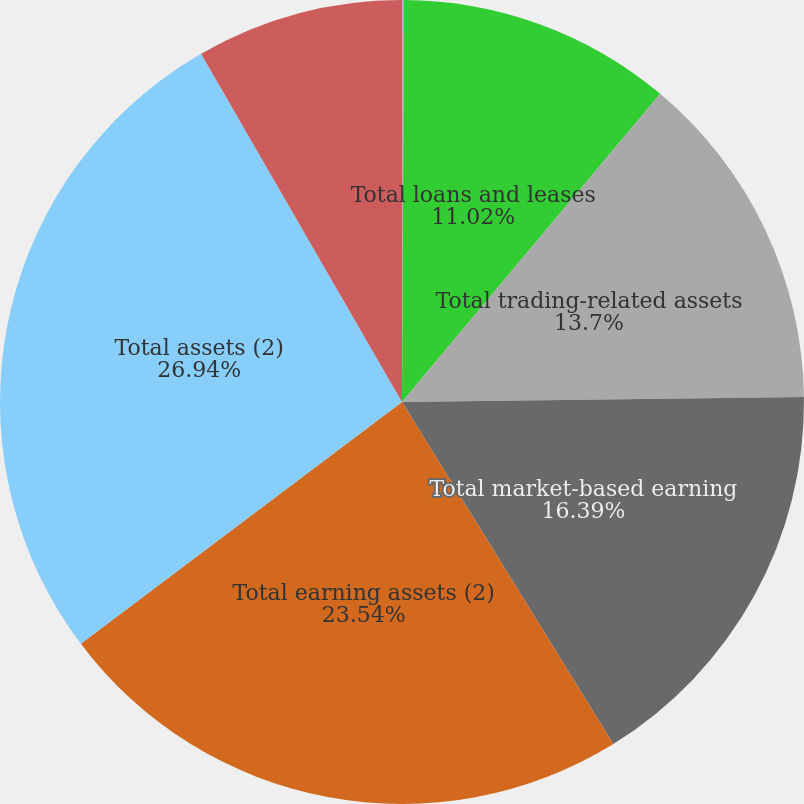Convert chart. <chart><loc_0><loc_0><loc_500><loc_500><pie_chart><fcel>(Dollars in millions)<fcel>Total loans and leases<fcel>Total trading-related assets<fcel>Total market-based earning<fcel>Total earning assets (2)<fcel>Total assets (2)<fcel>Total deposits<nl><fcel>0.08%<fcel>11.02%<fcel>13.7%<fcel>16.39%<fcel>23.54%<fcel>26.94%<fcel>8.33%<nl></chart> 